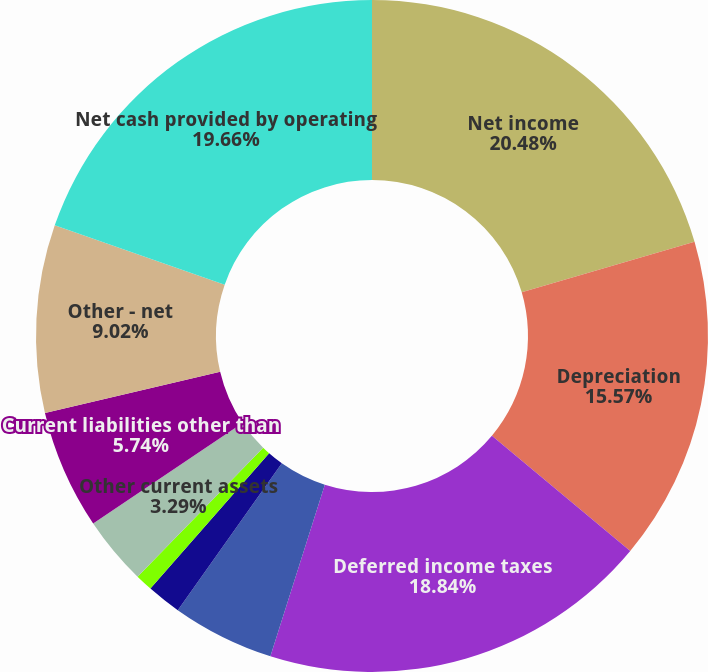<chart> <loc_0><loc_0><loc_500><loc_500><pie_chart><fcel>Net income<fcel>Depreciation<fcel>Deferred income taxes<fcel>Gains and losses on properties<fcel>Accounts receivable<fcel>Materials and supplies<fcel>Other current assets<fcel>Current liabilities other than<fcel>Other - net<fcel>Net cash provided by operating<nl><fcel>20.48%<fcel>15.57%<fcel>18.84%<fcel>4.92%<fcel>1.65%<fcel>0.83%<fcel>3.29%<fcel>5.74%<fcel>9.02%<fcel>19.66%<nl></chart> 